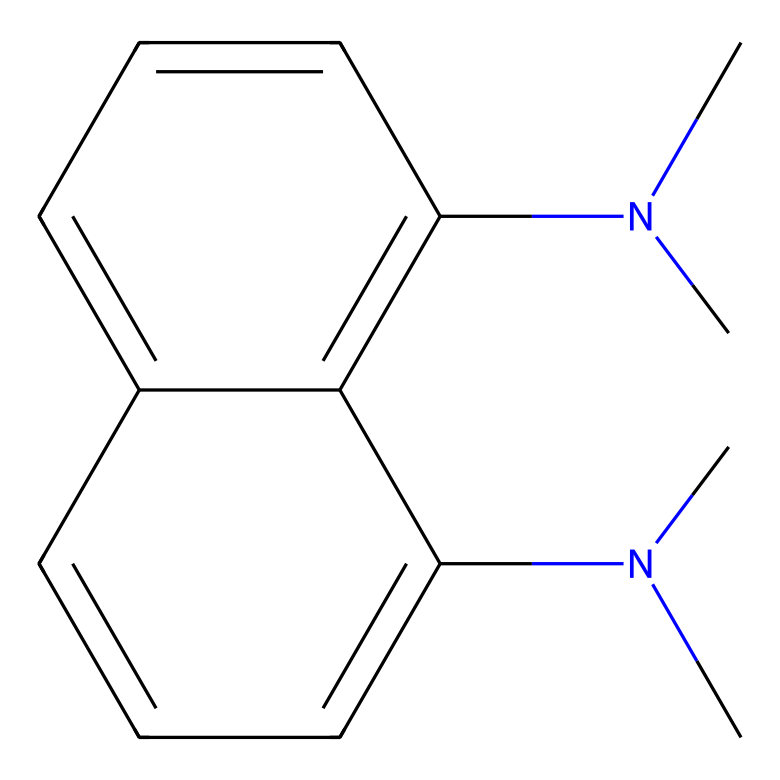What is the name of this chemical? The SMILES representation indicates the presence of two dimethylamino groups attached to a naphthalene structure. When these components are combined, the chemical is identified as 1,8-bis(dimethylamino)naphthalene.
Answer: 1,8-bis(dimethylamino)naphthalene How many nitrogen atoms are present? In the SMILES, there are two dimethylamino groups, each contributing one nitrogen atom. Therefore, summing these gives a total of two nitrogen atoms.
Answer: 2 What type of molecular structure is this chemical primarily based on? The chemical features a naphthalene backbone, which is a polycyclic aromatic hydrocarbon, thus indicating its structure is primarily based on this type of molecular framework.
Answer: Aromatic hydrocarbon What is the total number of carbon atoms in the structure? The naphthalene part contributes ten carbon atoms, and the two dimethylamino groups add an additional four carbon atoms (two from each group), leading to a total of fourteen carbon atoms.
Answer: 14 Why is 1,8-bis(dimethylamino)naphthalene referred to as a proton sponge? The presence of multiple basic dimethylamino groups enhances its ability to stabilize protons, making it very effective at capturing protons in a chemical reaction. This characteristic gives it the nickname "proton sponge."
Answer: Proton sponge What is the significance of the position of the amine groups in the structure? The positioning at the 1 and 8 positions of the naphthalene ring allows for maximum spatial separation of the dimethylamino groups, which facilitates efficient protonation and increases the molecule's basicity.
Answer: Increased basicity 